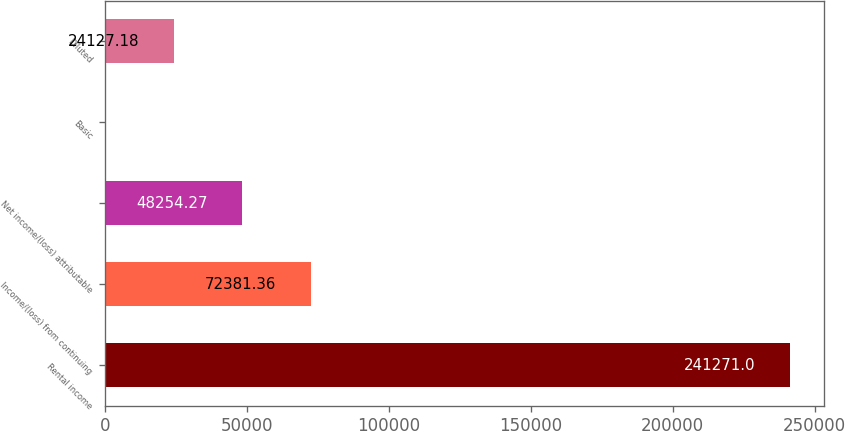Convert chart. <chart><loc_0><loc_0><loc_500><loc_500><bar_chart><fcel>Rental income<fcel>Income/(loss) from continuing<fcel>Net income/(loss) attributable<fcel>Basic<fcel>Diluted<nl><fcel>241271<fcel>72381.4<fcel>48254.3<fcel>0.09<fcel>24127.2<nl></chart> 